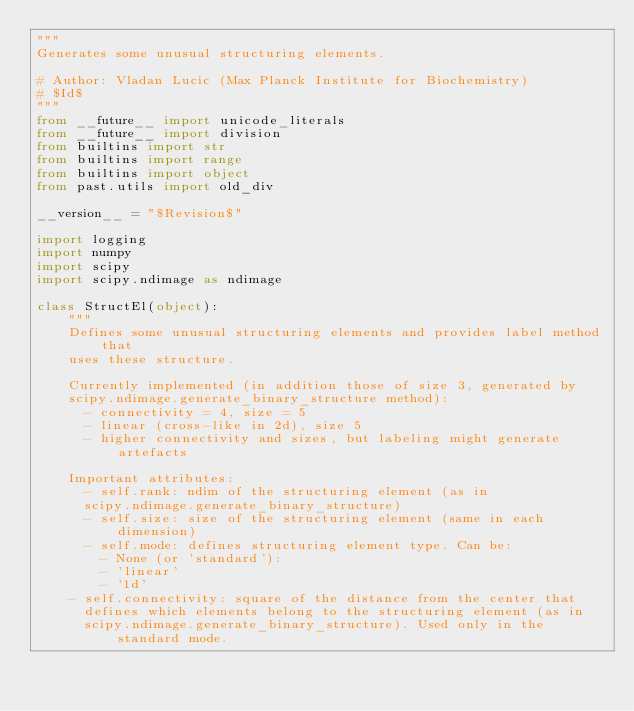Convert code to text. <code><loc_0><loc_0><loc_500><loc_500><_Python_>"""
Generates some unusual structuring elements.

# Author: Vladan Lucic (Max Planck Institute for Biochemistry)
# $Id$
"""
from __future__ import unicode_literals
from __future__ import division
from builtins import str
from builtins import range
from builtins import object
from past.utils import old_div

__version__ = "$Revision$"

import logging
import numpy
import scipy
import scipy.ndimage as ndimage

class StructEl(object):
    """
    Defines some unusual structuring elements and provides label method that 
    uses these structure.

    Currently implemented (in addition those of size 3, generated by
    scipy.ndimage.generate_binary_structure method):
      - connectivity = 4, size = 5
      - linear (cross-like in 2d), size 5
      - higher connectivity and sizes, but labeling might generate artefacts

    Important attributes:
      - self.rank: ndim of the structuring element (as in
      scipy.ndimage.generate_binary_structure)
      - self.size: size of the structuring element (same in each dimension)
      - self.mode: defines structuring element type. Can be:
        - None (or 'standard'):
        - 'linear'
        - '1d'
    - self.connectivity: square of the distance from the center that 
      defines which elements belong to the structuring element (as in
      scipy.ndimage.generate_binary_structure). Used only in the standard mode.</code> 